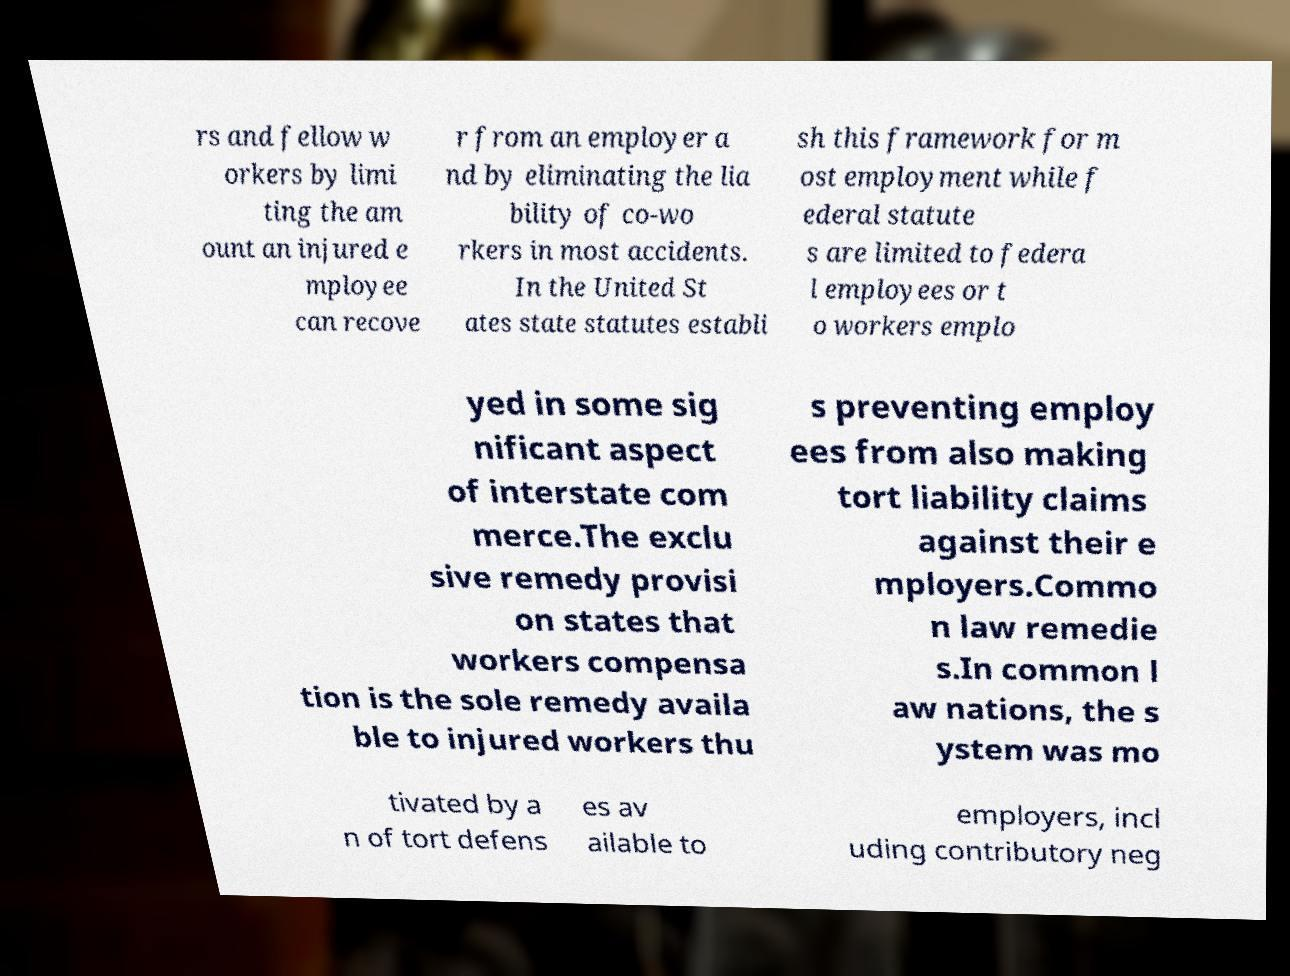Could you extract and type out the text from this image? rs and fellow w orkers by limi ting the am ount an injured e mployee can recove r from an employer a nd by eliminating the lia bility of co-wo rkers in most accidents. In the United St ates state statutes establi sh this framework for m ost employment while f ederal statute s are limited to federa l employees or t o workers emplo yed in some sig nificant aspect of interstate com merce.The exclu sive remedy provisi on states that workers compensa tion is the sole remedy availa ble to injured workers thu s preventing employ ees from also making tort liability claims against their e mployers.Commo n law remedie s.In common l aw nations, the s ystem was mo tivated by a n of tort defens es av ailable to employers, incl uding contributory neg 